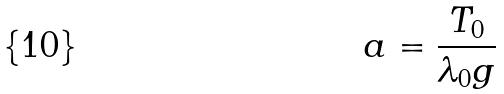Convert formula to latex. <formula><loc_0><loc_0><loc_500><loc_500>a = \frac { T _ { 0 } } { \lambda _ { 0 } g }</formula> 